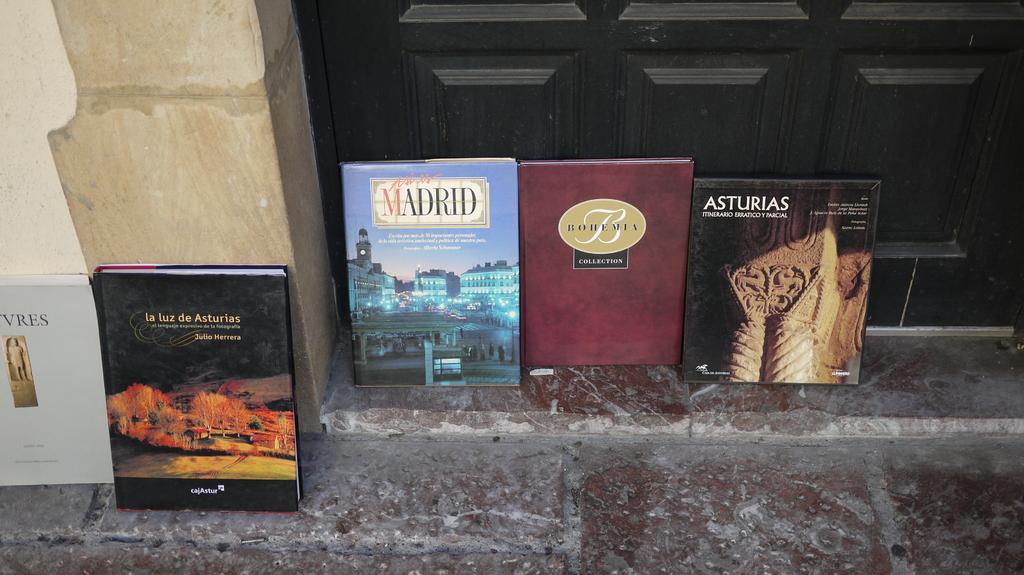What is the book on the end?
Give a very brief answer. Asturias. What city is shown on the blue book?
Offer a very short reply. Madrid. 